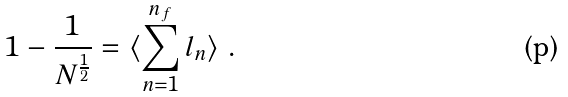<formula> <loc_0><loc_0><loc_500><loc_500>1 - \frac { 1 } { N ^ { \frac { 1 } { 2 } } } = \langle \sum _ { n = 1 } ^ { n _ { f } } l _ { n } \rangle \ .</formula> 